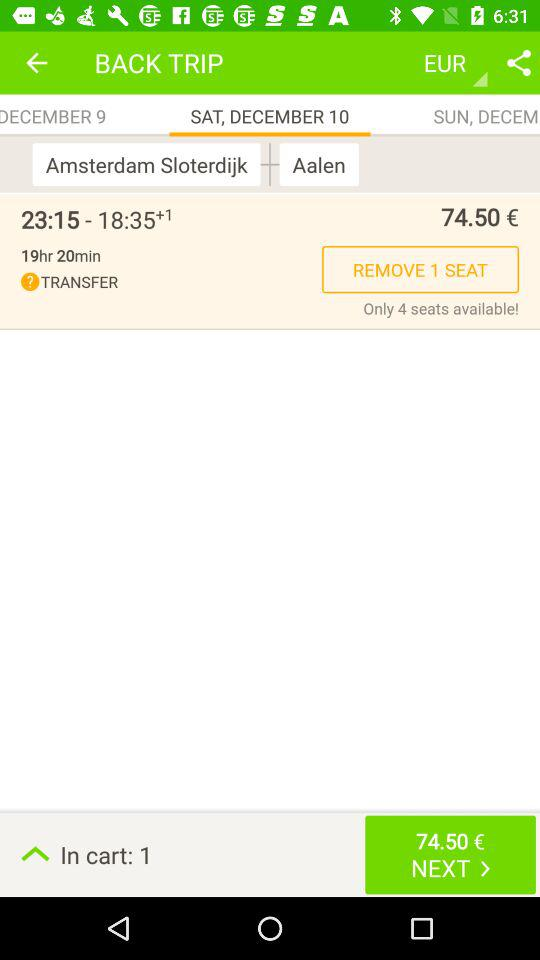How many seats are available? There are only 4 seats available. 